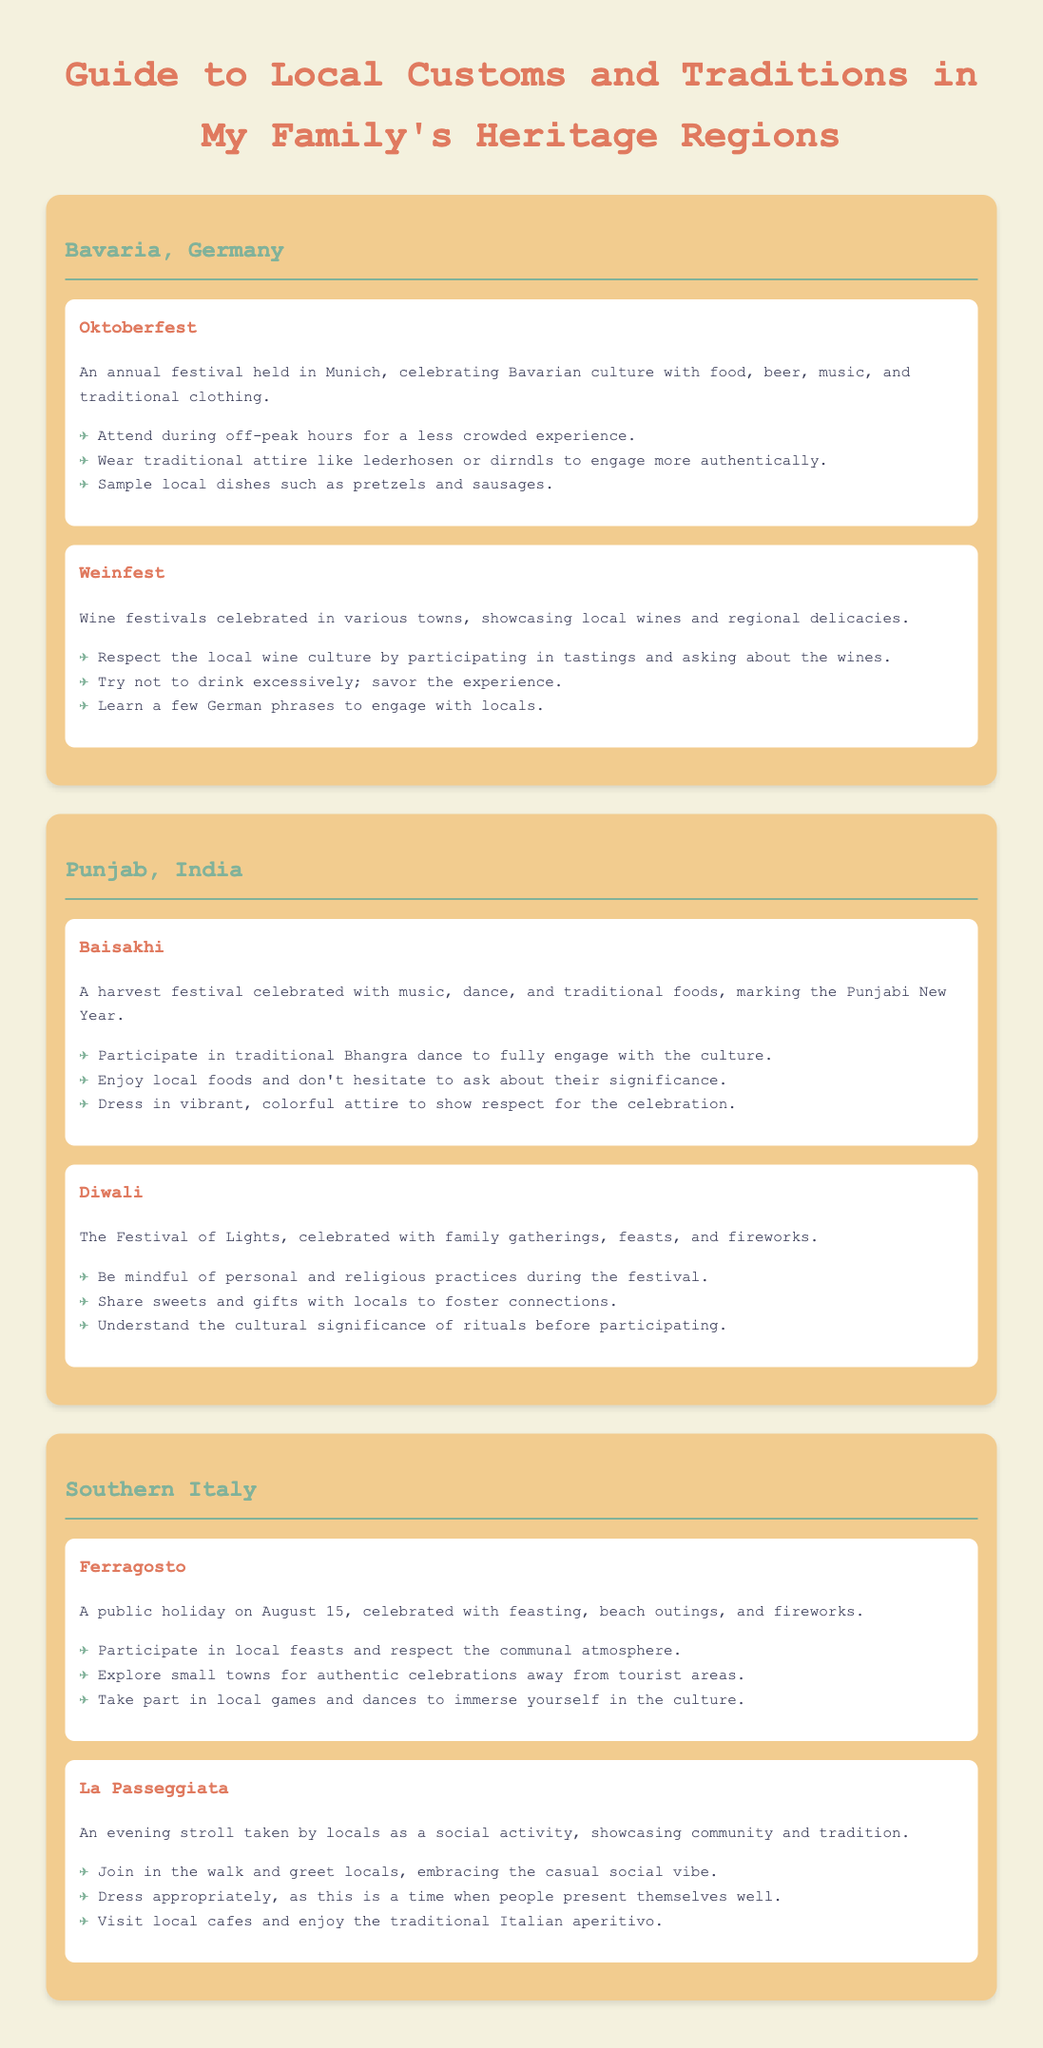What is the annual festival held in Munich? The annual festival celebrated in Munich is called Oktoberfest.
Answer: Oktoberfest What traditional attire is suggested for Oktoberfest? The document suggests wearing lederhosen or dirndls for a more authentic experience at Oktoberfest.
Answer: lederhosen or dirndls What is Baisakhi celebrated for? Baisakhi is celebrated to mark the Punjabi New Year and the harvest season.
Answer: Punjabi New Year Which drink culture is emphasized during Weinfest? The document highlights the importance of local wine culture during Weinfest.
Answer: local wine culture What is a recommended local activity during Ferragosto? The document recommends participating in local feasts as a way to celebrate Ferragosto.
Answer: local feasts What is the date of Ferragosto? Ferragosto is celebrated on August 15.
Answer: August 15 What do locals share during Diwali? Locals typically share sweets and gifts during Diwali to foster connections.
Answer: sweets and gifts What type of social activity is La Passeggiata? La Passeggiata is an evening stroll taken by locals as a social activity.
Answer: evening stroll 